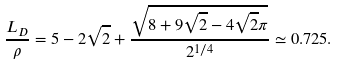Convert formula to latex. <formula><loc_0><loc_0><loc_500><loc_500>\frac { L _ { D } } { \rho } = 5 - 2 \sqrt { 2 } + \frac { \sqrt { 8 + 9 \sqrt { 2 } - 4 \sqrt { 2 } \pi } } { 2 ^ { 1 / 4 } } \simeq 0 . 7 2 5 .</formula> 